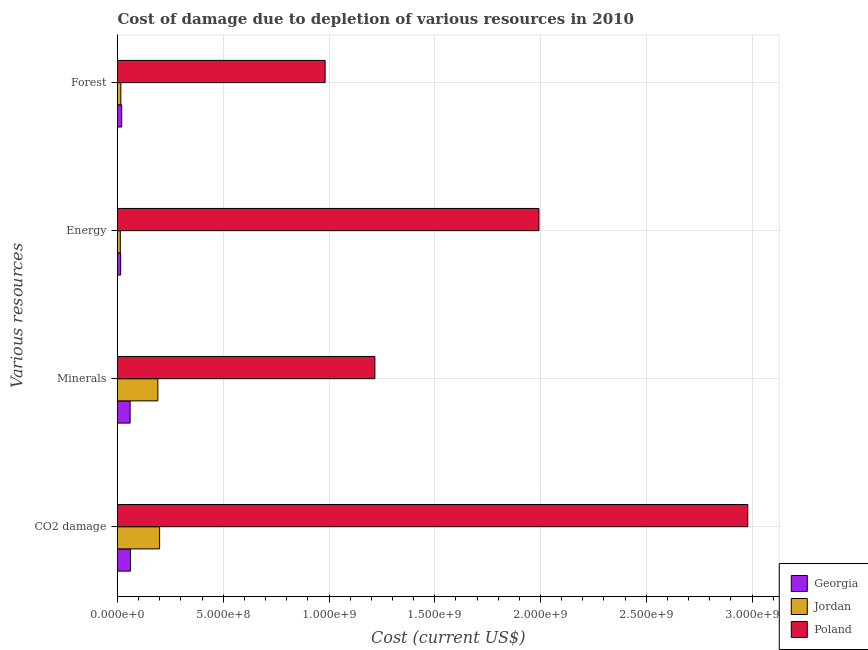Are the number of bars on each tick of the Y-axis equal?
Give a very brief answer. Yes. How many bars are there on the 3rd tick from the bottom?
Your response must be concise. 3. What is the label of the 1st group of bars from the top?
Provide a short and direct response. Forest. What is the cost of damage due to depletion of minerals in Jordan?
Your answer should be compact. 1.91e+08. Across all countries, what is the maximum cost of damage due to depletion of minerals?
Your response must be concise. 1.22e+09. Across all countries, what is the minimum cost of damage due to depletion of energy?
Provide a succinct answer. 1.33e+07. In which country was the cost of damage due to depletion of energy maximum?
Provide a succinct answer. Poland. In which country was the cost of damage due to depletion of coal minimum?
Offer a very short reply. Georgia. What is the total cost of damage due to depletion of minerals in the graph?
Your answer should be compact. 1.47e+09. What is the difference between the cost of damage due to depletion of forests in Georgia and that in Jordan?
Keep it short and to the point. 3.95e+06. What is the difference between the cost of damage due to depletion of forests in Georgia and the cost of damage due to depletion of minerals in Jordan?
Your answer should be compact. -1.71e+08. What is the average cost of damage due to depletion of forests per country?
Your answer should be very brief. 3.39e+08. What is the difference between the cost of damage due to depletion of coal and cost of damage due to depletion of forests in Jordan?
Offer a very short reply. 1.83e+08. What is the ratio of the cost of damage due to depletion of minerals in Jordan to that in Poland?
Your answer should be compact. 0.16. Is the difference between the cost of damage due to depletion of forests in Poland and Georgia greater than the difference between the cost of damage due to depletion of coal in Poland and Georgia?
Provide a succinct answer. No. What is the difference between the highest and the second highest cost of damage due to depletion of coal?
Your answer should be compact. 2.78e+09. What is the difference between the highest and the lowest cost of damage due to depletion of energy?
Your answer should be very brief. 1.98e+09. What does the 3rd bar from the top in Minerals represents?
Your answer should be very brief. Georgia. What does the 2nd bar from the bottom in Forest represents?
Make the answer very short. Jordan. Is it the case that in every country, the sum of the cost of damage due to depletion of coal and cost of damage due to depletion of minerals is greater than the cost of damage due to depletion of energy?
Give a very brief answer. Yes. What is the difference between two consecutive major ticks on the X-axis?
Provide a succinct answer. 5.00e+08. Are the values on the major ticks of X-axis written in scientific E-notation?
Make the answer very short. Yes. Does the graph contain any zero values?
Provide a succinct answer. No. Does the graph contain grids?
Offer a very short reply. Yes. Where does the legend appear in the graph?
Ensure brevity in your answer.  Bottom right. How many legend labels are there?
Ensure brevity in your answer.  3. How are the legend labels stacked?
Offer a very short reply. Vertical. What is the title of the graph?
Keep it short and to the point. Cost of damage due to depletion of various resources in 2010 . Does "Austria" appear as one of the legend labels in the graph?
Your response must be concise. No. What is the label or title of the X-axis?
Provide a short and direct response. Cost (current US$). What is the label or title of the Y-axis?
Your response must be concise. Various resources. What is the Cost (current US$) in Georgia in CO2 damage?
Your answer should be very brief. 6.14e+07. What is the Cost (current US$) in Jordan in CO2 damage?
Provide a succinct answer. 1.99e+08. What is the Cost (current US$) of Poland in CO2 damage?
Provide a short and direct response. 2.98e+09. What is the Cost (current US$) in Georgia in Minerals?
Ensure brevity in your answer.  5.97e+07. What is the Cost (current US$) of Jordan in Minerals?
Your response must be concise. 1.91e+08. What is the Cost (current US$) in Poland in Minerals?
Make the answer very short. 1.22e+09. What is the Cost (current US$) in Georgia in Energy?
Offer a very short reply. 1.50e+07. What is the Cost (current US$) of Jordan in Energy?
Provide a short and direct response. 1.33e+07. What is the Cost (current US$) in Poland in Energy?
Offer a terse response. 1.99e+09. What is the Cost (current US$) in Georgia in Forest?
Your answer should be very brief. 1.98e+07. What is the Cost (current US$) in Jordan in Forest?
Offer a very short reply. 1.58e+07. What is the Cost (current US$) in Poland in Forest?
Make the answer very short. 9.82e+08. Across all Various resources, what is the maximum Cost (current US$) of Georgia?
Your response must be concise. 6.14e+07. Across all Various resources, what is the maximum Cost (current US$) of Jordan?
Give a very brief answer. 1.99e+08. Across all Various resources, what is the maximum Cost (current US$) in Poland?
Ensure brevity in your answer.  2.98e+09. Across all Various resources, what is the minimum Cost (current US$) of Georgia?
Keep it short and to the point. 1.50e+07. Across all Various resources, what is the minimum Cost (current US$) in Jordan?
Give a very brief answer. 1.33e+07. Across all Various resources, what is the minimum Cost (current US$) of Poland?
Provide a short and direct response. 9.82e+08. What is the total Cost (current US$) in Georgia in the graph?
Offer a terse response. 1.56e+08. What is the total Cost (current US$) of Jordan in the graph?
Provide a short and direct response. 4.19e+08. What is the total Cost (current US$) of Poland in the graph?
Your response must be concise. 7.17e+09. What is the difference between the Cost (current US$) of Georgia in CO2 damage and that in Minerals?
Offer a very short reply. 1.73e+06. What is the difference between the Cost (current US$) of Jordan in CO2 damage and that in Minerals?
Give a very brief answer. 8.30e+06. What is the difference between the Cost (current US$) in Poland in CO2 damage and that in Minerals?
Keep it short and to the point. 1.76e+09. What is the difference between the Cost (current US$) in Georgia in CO2 damage and that in Energy?
Your answer should be very brief. 4.64e+07. What is the difference between the Cost (current US$) in Jordan in CO2 damage and that in Energy?
Provide a succinct answer. 1.86e+08. What is the difference between the Cost (current US$) in Poland in CO2 damage and that in Energy?
Provide a succinct answer. 9.87e+08. What is the difference between the Cost (current US$) of Georgia in CO2 damage and that in Forest?
Offer a terse response. 4.16e+07. What is the difference between the Cost (current US$) of Jordan in CO2 damage and that in Forest?
Your answer should be very brief. 1.83e+08. What is the difference between the Cost (current US$) in Poland in CO2 damage and that in Forest?
Make the answer very short. 2.00e+09. What is the difference between the Cost (current US$) in Georgia in Minerals and that in Energy?
Your response must be concise. 4.47e+07. What is the difference between the Cost (current US$) of Jordan in Minerals and that in Energy?
Give a very brief answer. 1.77e+08. What is the difference between the Cost (current US$) in Poland in Minerals and that in Energy?
Your response must be concise. -7.76e+08. What is the difference between the Cost (current US$) of Georgia in Minerals and that in Forest?
Give a very brief answer. 3.99e+07. What is the difference between the Cost (current US$) of Jordan in Minerals and that in Forest?
Your answer should be very brief. 1.75e+08. What is the difference between the Cost (current US$) of Poland in Minerals and that in Forest?
Offer a terse response. 2.35e+08. What is the difference between the Cost (current US$) in Georgia in Energy and that in Forest?
Keep it short and to the point. -4.77e+06. What is the difference between the Cost (current US$) in Jordan in Energy and that in Forest?
Offer a very short reply. -2.51e+06. What is the difference between the Cost (current US$) of Poland in Energy and that in Forest?
Provide a succinct answer. 1.01e+09. What is the difference between the Cost (current US$) in Georgia in CO2 damage and the Cost (current US$) in Jordan in Minerals?
Offer a very short reply. -1.29e+08. What is the difference between the Cost (current US$) in Georgia in CO2 damage and the Cost (current US$) in Poland in Minerals?
Your answer should be compact. -1.16e+09. What is the difference between the Cost (current US$) of Jordan in CO2 damage and the Cost (current US$) of Poland in Minerals?
Keep it short and to the point. -1.02e+09. What is the difference between the Cost (current US$) of Georgia in CO2 damage and the Cost (current US$) of Jordan in Energy?
Your response must be concise. 4.81e+07. What is the difference between the Cost (current US$) in Georgia in CO2 damage and the Cost (current US$) in Poland in Energy?
Provide a succinct answer. -1.93e+09. What is the difference between the Cost (current US$) in Jordan in CO2 damage and the Cost (current US$) in Poland in Energy?
Provide a succinct answer. -1.79e+09. What is the difference between the Cost (current US$) in Georgia in CO2 damage and the Cost (current US$) in Jordan in Forest?
Ensure brevity in your answer.  4.56e+07. What is the difference between the Cost (current US$) in Georgia in CO2 damage and the Cost (current US$) in Poland in Forest?
Provide a short and direct response. -9.20e+08. What is the difference between the Cost (current US$) of Jordan in CO2 damage and the Cost (current US$) of Poland in Forest?
Offer a very short reply. -7.83e+08. What is the difference between the Cost (current US$) of Georgia in Minerals and the Cost (current US$) of Jordan in Energy?
Your response must be concise. 4.63e+07. What is the difference between the Cost (current US$) of Georgia in Minerals and the Cost (current US$) of Poland in Energy?
Your response must be concise. -1.93e+09. What is the difference between the Cost (current US$) in Jordan in Minerals and the Cost (current US$) in Poland in Energy?
Offer a terse response. -1.80e+09. What is the difference between the Cost (current US$) in Georgia in Minerals and the Cost (current US$) in Jordan in Forest?
Offer a terse response. 4.38e+07. What is the difference between the Cost (current US$) in Georgia in Minerals and the Cost (current US$) in Poland in Forest?
Your answer should be very brief. -9.22e+08. What is the difference between the Cost (current US$) in Jordan in Minerals and the Cost (current US$) in Poland in Forest?
Ensure brevity in your answer.  -7.91e+08. What is the difference between the Cost (current US$) in Georgia in Energy and the Cost (current US$) in Jordan in Forest?
Keep it short and to the point. -8.20e+05. What is the difference between the Cost (current US$) in Georgia in Energy and the Cost (current US$) in Poland in Forest?
Make the answer very short. -9.67e+08. What is the difference between the Cost (current US$) in Jordan in Energy and the Cost (current US$) in Poland in Forest?
Provide a succinct answer. -9.68e+08. What is the average Cost (current US$) in Georgia per Various resources?
Your answer should be very brief. 3.89e+07. What is the average Cost (current US$) of Jordan per Various resources?
Ensure brevity in your answer.  1.05e+08. What is the average Cost (current US$) in Poland per Various resources?
Keep it short and to the point. 1.79e+09. What is the difference between the Cost (current US$) in Georgia and Cost (current US$) in Jordan in CO2 damage?
Keep it short and to the point. -1.38e+08. What is the difference between the Cost (current US$) of Georgia and Cost (current US$) of Poland in CO2 damage?
Make the answer very short. -2.92e+09. What is the difference between the Cost (current US$) in Jordan and Cost (current US$) in Poland in CO2 damage?
Give a very brief answer. -2.78e+09. What is the difference between the Cost (current US$) in Georgia and Cost (current US$) in Jordan in Minerals?
Your answer should be very brief. -1.31e+08. What is the difference between the Cost (current US$) in Georgia and Cost (current US$) in Poland in Minerals?
Your answer should be very brief. -1.16e+09. What is the difference between the Cost (current US$) of Jordan and Cost (current US$) of Poland in Minerals?
Offer a terse response. -1.03e+09. What is the difference between the Cost (current US$) in Georgia and Cost (current US$) in Jordan in Energy?
Your answer should be very brief. 1.69e+06. What is the difference between the Cost (current US$) in Georgia and Cost (current US$) in Poland in Energy?
Give a very brief answer. -1.98e+09. What is the difference between the Cost (current US$) of Jordan and Cost (current US$) of Poland in Energy?
Give a very brief answer. -1.98e+09. What is the difference between the Cost (current US$) of Georgia and Cost (current US$) of Jordan in Forest?
Offer a very short reply. 3.95e+06. What is the difference between the Cost (current US$) of Georgia and Cost (current US$) of Poland in Forest?
Offer a very short reply. -9.62e+08. What is the difference between the Cost (current US$) of Jordan and Cost (current US$) of Poland in Forest?
Your answer should be compact. -9.66e+08. What is the ratio of the Cost (current US$) of Georgia in CO2 damage to that in Minerals?
Provide a short and direct response. 1.03. What is the ratio of the Cost (current US$) of Jordan in CO2 damage to that in Minerals?
Make the answer very short. 1.04. What is the ratio of the Cost (current US$) of Poland in CO2 damage to that in Minerals?
Your response must be concise. 2.45. What is the ratio of the Cost (current US$) in Georgia in CO2 damage to that in Energy?
Your answer should be very brief. 4.09. What is the ratio of the Cost (current US$) of Jordan in CO2 damage to that in Energy?
Your answer should be very brief. 14.96. What is the ratio of the Cost (current US$) in Poland in CO2 damage to that in Energy?
Ensure brevity in your answer.  1.5. What is the ratio of the Cost (current US$) of Georgia in CO2 damage to that in Forest?
Provide a succinct answer. 3.11. What is the ratio of the Cost (current US$) in Jordan in CO2 damage to that in Forest?
Give a very brief answer. 12.59. What is the ratio of the Cost (current US$) in Poland in CO2 damage to that in Forest?
Provide a short and direct response. 3.04. What is the ratio of the Cost (current US$) of Georgia in Minerals to that in Energy?
Provide a succinct answer. 3.98. What is the ratio of the Cost (current US$) in Jordan in Minerals to that in Energy?
Give a very brief answer. 14.33. What is the ratio of the Cost (current US$) in Poland in Minerals to that in Energy?
Ensure brevity in your answer.  0.61. What is the ratio of the Cost (current US$) in Georgia in Minerals to that in Forest?
Provide a short and direct response. 3.02. What is the ratio of the Cost (current US$) of Jordan in Minerals to that in Forest?
Your response must be concise. 12.06. What is the ratio of the Cost (current US$) of Poland in Minerals to that in Forest?
Offer a terse response. 1.24. What is the ratio of the Cost (current US$) in Georgia in Energy to that in Forest?
Ensure brevity in your answer.  0.76. What is the ratio of the Cost (current US$) of Jordan in Energy to that in Forest?
Provide a succinct answer. 0.84. What is the ratio of the Cost (current US$) in Poland in Energy to that in Forest?
Offer a terse response. 2.03. What is the difference between the highest and the second highest Cost (current US$) in Georgia?
Keep it short and to the point. 1.73e+06. What is the difference between the highest and the second highest Cost (current US$) of Jordan?
Offer a very short reply. 8.30e+06. What is the difference between the highest and the second highest Cost (current US$) in Poland?
Give a very brief answer. 9.87e+08. What is the difference between the highest and the lowest Cost (current US$) in Georgia?
Your answer should be compact. 4.64e+07. What is the difference between the highest and the lowest Cost (current US$) in Jordan?
Provide a succinct answer. 1.86e+08. What is the difference between the highest and the lowest Cost (current US$) of Poland?
Your response must be concise. 2.00e+09. 